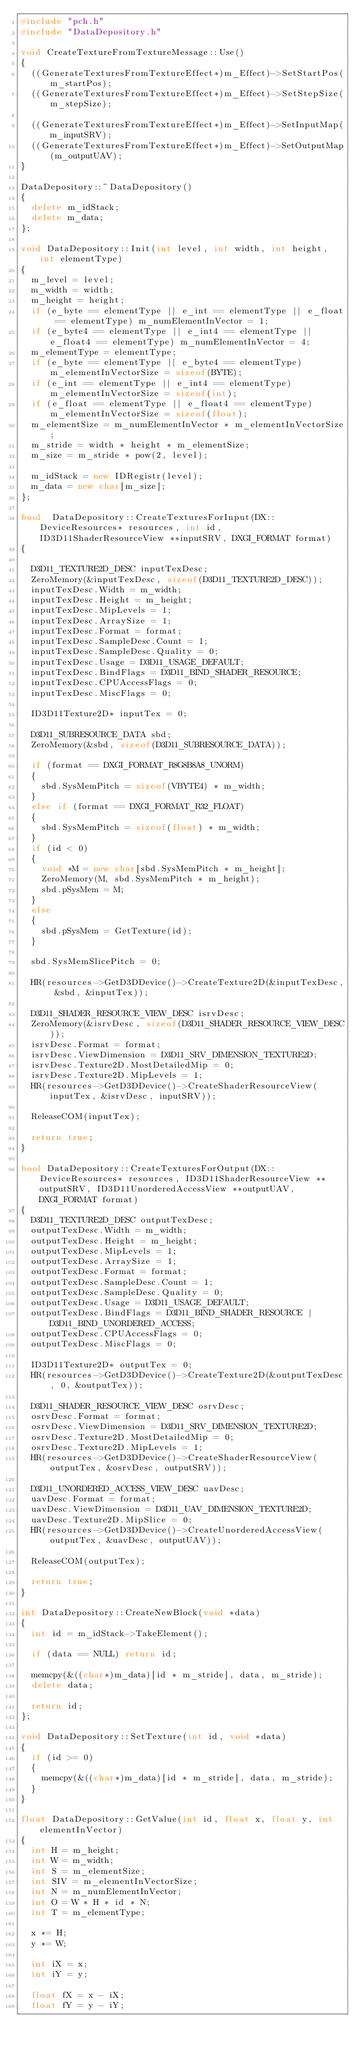<code> <loc_0><loc_0><loc_500><loc_500><_C++_>#include "pch.h"
#include "DataDepository.h"

void CreateTextureFromTextureMessage::Use()
{
	((GenerateTexturesFromTextureEffect*)m_Effect)->SetStartPos(m_startPos);
	((GenerateTexturesFromTextureEffect*)m_Effect)->SetStepSize(m_stepSize);

	((GenerateTexturesFromTextureEffect*)m_Effect)->SetInputMap(m_inputSRV);
	((GenerateTexturesFromTextureEffect*)m_Effect)->SetOutputMap(m_outputUAV);
}

DataDepository::~DataDepository()
{
	delete m_idStack;
	delete m_data;
};

void DataDepository::Init(int level, int width, int height, int elementType)
{
	m_level = level;
	m_width = width;
	m_height = height;
	if (e_byte == elementType || e_int == elementType || e_float == elementType) m_numElementInVector = 1;
	if (e_byte4 == elementType || e_int4 == elementType || e_float4 == elementType) m_numElementInVector = 4;
	m_elementType = elementType;
	if (e_byte == elementType || e_byte4 == elementType)	m_elementInVectorSize = sizeof(BYTE);
	if (e_int == elementType || e_int4 == elementType)	m_elementInVectorSize = sizeof(int);
	if (e_float == elementType || e_float4 == elementType)	m_elementInVectorSize = sizeof(float);
	m_elementSize = m_numElementInVector * m_elementInVectorSize;
	m_stride = width * height * m_elementSize;
	m_size = m_stride * pow(2, level);

	m_idStack = new IDRegistr(level);
	m_data = new char[m_size];
};

bool  DataDepository::CreateTexturesForInput(DX::DeviceResources* resources, int id, ID3D11ShaderResourceView **inputSRV, DXGI_FORMAT format)
{

	D3D11_TEXTURE2D_DESC inputTexDesc;
	ZeroMemory(&inputTexDesc, sizeof(D3D11_TEXTURE2D_DESC));
	inputTexDesc.Width = m_width;
	inputTexDesc.Height = m_height;
	inputTexDesc.MipLevels = 1;
	inputTexDesc.ArraySize = 1;
	inputTexDesc.Format = format;
	inputTexDesc.SampleDesc.Count = 1;
	inputTexDesc.SampleDesc.Quality = 0;
	inputTexDesc.Usage = D3D11_USAGE_DEFAULT;
	inputTexDesc.BindFlags = D3D11_BIND_SHADER_RESOURCE;
	inputTexDesc.CPUAccessFlags = 0;
	inputTexDesc.MiscFlags = 0;

	ID3D11Texture2D* inputTex = 0;

	D3D11_SUBRESOURCE_DATA sbd;
	ZeroMemory(&sbd, sizeof(D3D11_SUBRESOURCE_DATA));

	if (format == DXGI_FORMAT_R8G8B8A8_UNORM)
	{
		sbd.SysMemPitch = sizeof(VBYTE4) * m_width;
	}
	else if (format == DXGI_FORMAT_R32_FLOAT)
	{
		sbd.SysMemPitch = sizeof(float) * m_width;
	}
	if (id < 0)
	{
		void *M = new char[sbd.SysMemPitch * m_height];
		ZeroMemory(M, sbd.SysMemPitch * m_height);
		sbd.pSysMem = M;
	}
	else
	{
		sbd.pSysMem = GetTexture(id);
	}

	sbd.SysMemSlicePitch = 0;

	HR(resources->GetD3DDevice()->CreateTexture2D(&inputTexDesc, &sbd, &inputTex));

	D3D11_SHADER_RESOURCE_VIEW_DESC isrvDesc;
	ZeroMemory(&isrvDesc, sizeof(D3D11_SHADER_RESOURCE_VIEW_DESC));
	isrvDesc.Format = format;
	isrvDesc.ViewDimension = D3D11_SRV_DIMENSION_TEXTURE2D;
	isrvDesc.Texture2D.MostDetailedMip = 0;
	isrvDesc.Texture2D.MipLevels = 1;
	HR(resources->GetD3DDevice()->CreateShaderResourceView(inputTex, &isrvDesc, inputSRV));

	ReleaseCOM(inputTex);

	return true;
}

bool DataDepository::CreateTexturesForOutput(DX::DeviceResources* resources, ID3D11ShaderResourceView **outputSRV, ID3D11UnorderedAccessView **outputUAV, DXGI_FORMAT format)
{
	D3D11_TEXTURE2D_DESC outputTexDesc;
	outputTexDesc.Width = m_width;
	outputTexDesc.Height = m_height;
	outputTexDesc.MipLevels = 1;
	outputTexDesc.ArraySize = 1;
	outputTexDesc.Format = format;
	outputTexDesc.SampleDesc.Count = 1;
	outputTexDesc.SampleDesc.Quality = 0;
	outputTexDesc.Usage = D3D11_USAGE_DEFAULT;
	outputTexDesc.BindFlags = D3D11_BIND_SHADER_RESOURCE | D3D11_BIND_UNORDERED_ACCESS;
	outputTexDesc.CPUAccessFlags = 0;
	outputTexDesc.MiscFlags = 0;

	ID3D11Texture2D* outputTex = 0;
	HR(resources->GetD3DDevice()->CreateTexture2D(&outputTexDesc, 0, &outputTex));

	D3D11_SHADER_RESOURCE_VIEW_DESC osrvDesc;
	osrvDesc.Format = format;
	osrvDesc.ViewDimension = D3D11_SRV_DIMENSION_TEXTURE2D;
	osrvDesc.Texture2D.MostDetailedMip = 0;
	osrvDesc.Texture2D.MipLevels = 1;
	HR(resources->GetD3DDevice()->CreateShaderResourceView(outputTex, &osrvDesc, outputSRV));

	D3D11_UNORDERED_ACCESS_VIEW_DESC uavDesc;
	uavDesc.Format = format;
	uavDesc.ViewDimension = D3D11_UAV_DIMENSION_TEXTURE2D;
	uavDesc.Texture2D.MipSlice = 0;
	HR(resources->GetD3DDevice()->CreateUnorderedAccessView(outputTex, &uavDesc, outputUAV));

	ReleaseCOM(outputTex);

	return true;
}

int DataDepository::CreateNewBlock(void *data)
{
	int id = m_idStack->TakeElement();

	if (data == NULL) return id;

	memcpy(&((char*)m_data)[id * m_stride], data, m_stride);
	delete data;

	return id;
};

void DataDepository::SetTexture(int id, void *data)
{
	if (id >= 0)
	{
		memcpy(&((char*)m_data)[id * m_stride], data, m_stride);
	}
}

float DataDepository::GetValue(int id, float x, float y, int elementInVector)
{
	int H = m_height;
	int W = m_width;
	int S = m_elementSize;
	int SIV = m_elementInVectorSize;
	int N = m_numElementInVector;
	int O = W * H * id * N;
	int T = m_elementType;

	x *= H;
	y *= W;

	int iX = x;
	int	iY = y;

	float fX = x - iX;
	float fY = y - iY;
</code> 